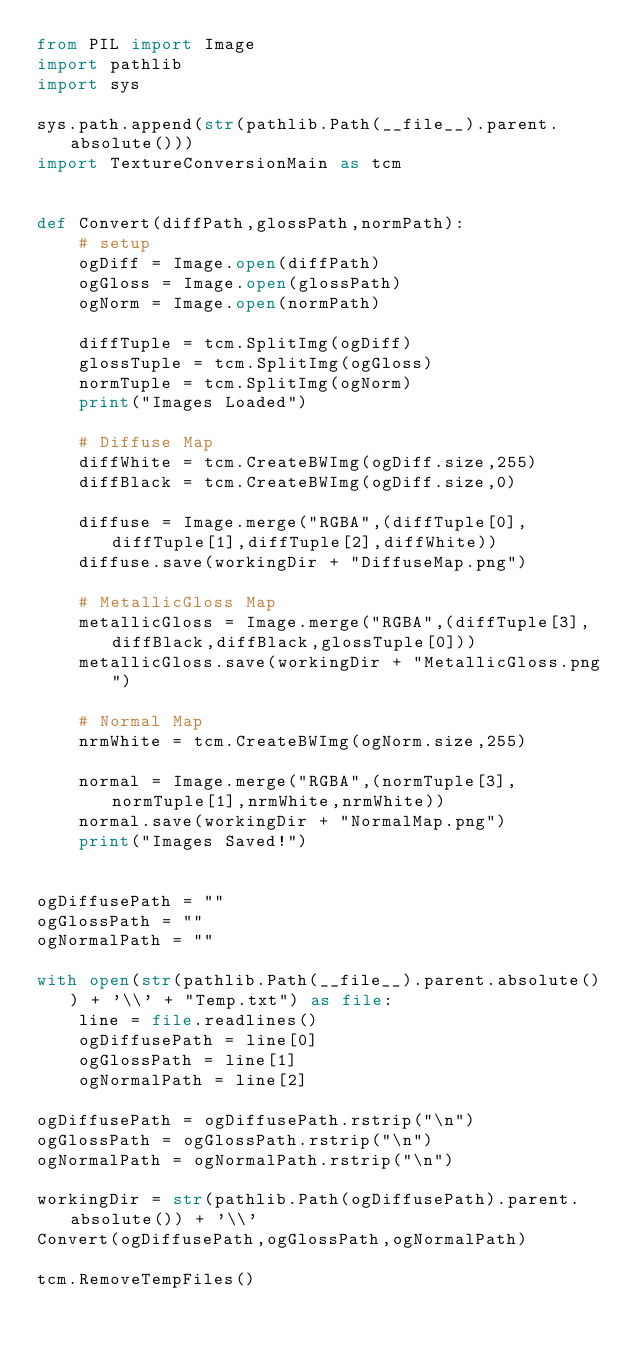Convert code to text. <code><loc_0><loc_0><loc_500><loc_500><_Python_>from PIL import Image
import pathlib
import sys

sys.path.append(str(pathlib.Path(__file__).parent.absolute()))
import TextureConversionMain as tcm


def Convert(diffPath,glossPath,normPath):
    # setup
    ogDiff = Image.open(diffPath)
    ogGloss = Image.open(glossPath)
    ogNorm = Image.open(normPath)

    diffTuple = tcm.SplitImg(ogDiff)
    glossTuple = tcm.SplitImg(ogGloss)
    normTuple = tcm.SplitImg(ogNorm)
    print("Images Loaded")

    # Diffuse Map
    diffWhite = tcm.CreateBWImg(ogDiff.size,255)
    diffBlack = tcm.CreateBWImg(ogDiff.size,0)
    
    diffuse = Image.merge("RGBA",(diffTuple[0],diffTuple[1],diffTuple[2],diffWhite))
    diffuse.save(workingDir + "DiffuseMap.png")

    # MetallicGloss Map
    metallicGloss = Image.merge("RGBA",(diffTuple[3],diffBlack,diffBlack,glossTuple[0]))
    metallicGloss.save(workingDir + "MetallicGloss.png")

    # Normal Map
    nrmWhite = tcm.CreateBWImg(ogNorm.size,255)
    
    normal = Image.merge("RGBA",(normTuple[3],normTuple[1],nrmWhite,nrmWhite))
    normal.save(workingDir + "NormalMap.png")
    print("Images Saved!")


ogDiffusePath = ""
ogGlossPath = ""
ogNormalPath = ""

with open(str(pathlib.Path(__file__).parent.absolute()) + '\\' + "Temp.txt") as file:
    line = file.readlines()
    ogDiffusePath = line[0]
    ogGlossPath = line[1]
    ogNormalPath = line[2]

ogDiffusePath = ogDiffusePath.rstrip("\n")
ogGlossPath = ogGlossPath.rstrip("\n")
ogNormalPath = ogNormalPath.rstrip("\n")

workingDir = str(pathlib.Path(ogDiffusePath).parent.absolute()) + '\\'
Convert(ogDiffusePath,ogGlossPath,ogNormalPath)

tcm.RemoveTempFiles()
</code> 